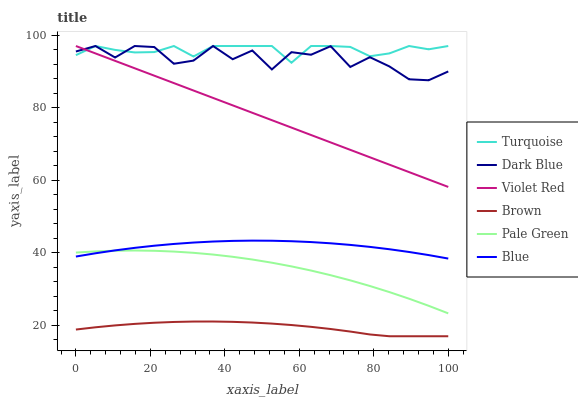Does Brown have the minimum area under the curve?
Answer yes or no. Yes. Does Turquoise have the maximum area under the curve?
Answer yes or no. Yes. Does Turquoise have the minimum area under the curve?
Answer yes or no. No. Does Brown have the maximum area under the curve?
Answer yes or no. No. Is Violet Red the smoothest?
Answer yes or no. Yes. Is Dark Blue the roughest?
Answer yes or no. Yes. Is Brown the smoothest?
Answer yes or no. No. Is Brown the roughest?
Answer yes or no. No. Does Brown have the lowest value?
Answer yes or no. Yes. Does Turquoise have the lowest value?
Answer yes or no. No. Does Dark Blue have the highest value?
Answer yes or no. Yes. Does Brown have the highest value?
Answer yes or no. No. Is Blue less than Violet Red?
Answer yes or no. Yes. Is Violet Red greater than Pale Green?
Answer yes or no. Yes. Does Turquoise intersect Violet Red?
Answer yes or no. Yes. Is Turquoise less than Violet Red?
Answer yes or no. No. Is Turquoise greater than Violet Red?
Answer yes or no. No. Does Blue intersect Violet Red?
Answer yes or no. No. 